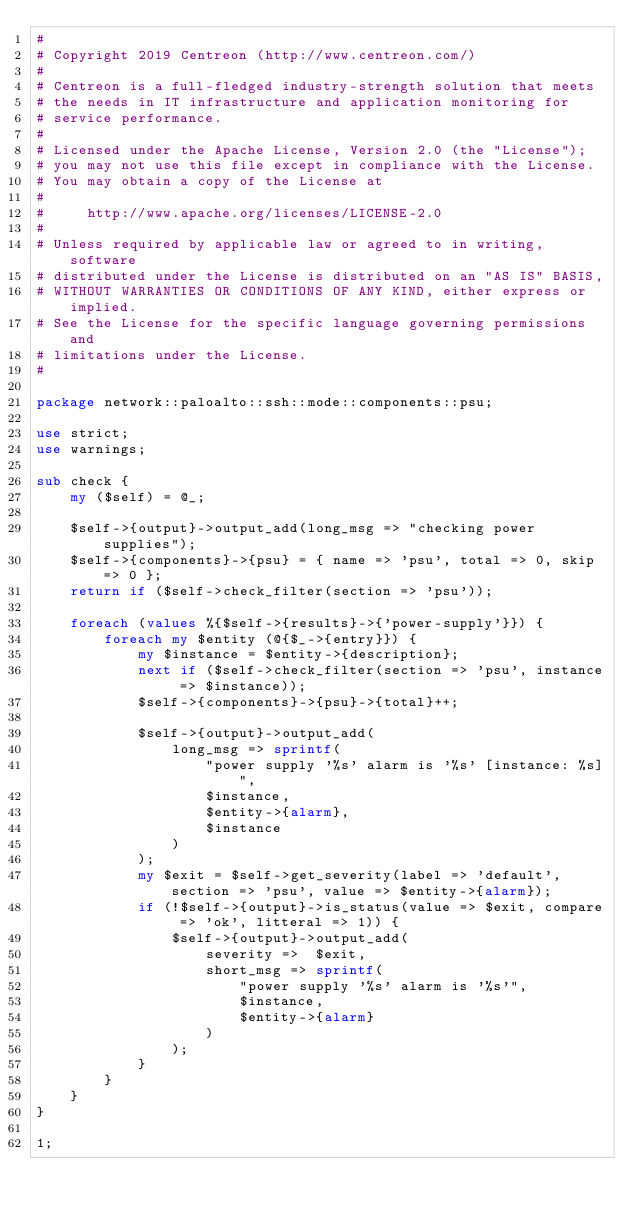<code> <loc_0><loc_0><loc_500><loc_500><_Perl_>#
# Copyright 2019 Centreon (http://www.centreon.com/)
#
# Centreon is a full-fledged industry-strength solution that meets
# the needs in IT infrastructure and application monitoring for
# service performance.
#
# Licensed under the Apache License, Version 2.0 (the "License");
# you may not use this file except in compliance with the License.
# You may obtain a copy of the License at
#
#     http://www.apache.org/licenses/LICENSE-2.0
#
# Unless required by applicable law or agreed to in writing, software
# distributed under the License is distributed on an "AS IS" BASIS,
# WITHOUT WARRANTIES OR CONDITIONS OF ANY KIND, either express or implied.
# See the License for the specific language governing permissions and
# limitations under the License.
#

package network::paloalto::ssh::mode::components::psu;

use strict;
use warnings;

sub check {
    my ($self) = @_;

    $self->{output}->output_add(long_msg => "checking power supplies");
    $self->{components}->{psu} = { name => 'psu', total => 0, skip => 0 };
    return if ($self->check_filter(section => 'psu'));

    foreach (values %{$self->{results}->{'power-supply'}}) {
        foreach my $entity (@{$_->{entry}}) {
            my $instance = $entity->{description};
            next if ($self->check_filter(section => 'psu', instance => $instance));
            $self->{components}->{psu}->{total}++;

            $self->{output}->output_add(
                long_msg => sprintf(
                    "power supply '%s' alarm is '%s' [instance: %s]",
                    $instance,
                    $entity->{alarm},
                    $instance
                )
            );
            my $exit = $self->get_severity(label => 'default', section => 'psu', value => $entity->{alarm});
            if (!$self->{output}->is_status(value => $exit, compare => 'ok', litteral => 1)) {
                $self->{output}->output_add(
                    severity =>  $exit,
                    short_msg => sprintf(
                        "power supply '%s' alarm is '%s'",
                        $instance,
                        $entity->{alarm}
                    )
                );
            }
        }
    }
}

1;
</code> 